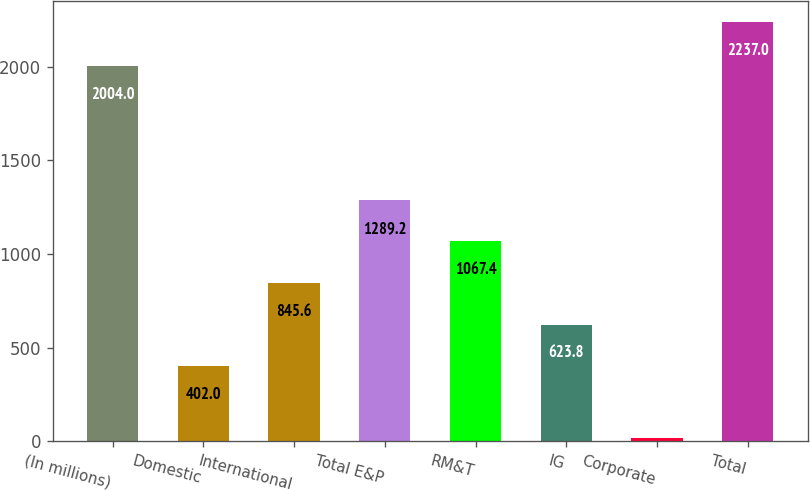Convert chart to OTSL. <chart><loc_0><loc_0><loc_500><loc_500><bar_chart><fcel>(In millions)<fcel>Domestic<fcel>International<fcel>Total E&P<fcel>RM&T<fcel>IG<fcel>Corporate<fcel>Total<nl><fcel>2004<fcel>402<fcel>845.6<fcel>1289.2<fcel>1067.4<fcel>623.8<fcel>19<fcel>2237<nl></chart> 